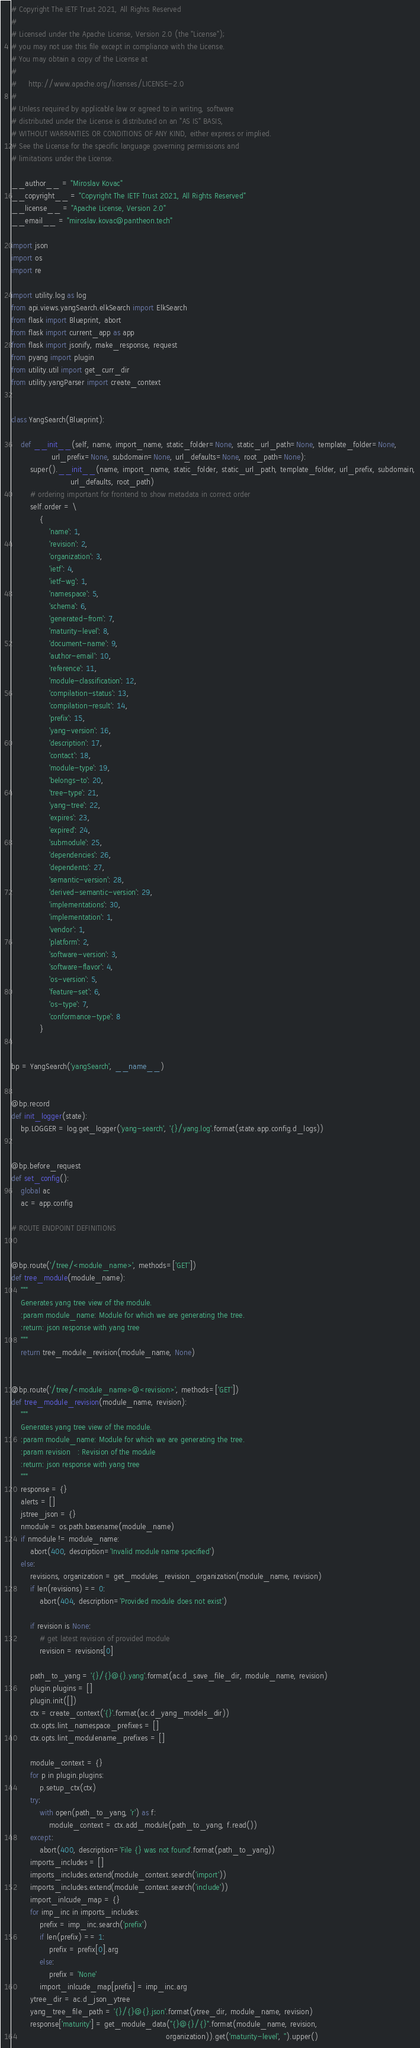<code> <loc_0><loc_0><loc_500><loc_500><_Python_># Copyright The IETF Trust 2021, All Rights Reserved
#
# Licensed under the Apache License, Version 2.0 (the "License");
# you may not use this file except in compliance with the License.
# You may obtain a copy of the License at
#
#     http://www.apache.org/licenses/LICENSE-2.0
#
# Unless required by applicable law or agreed to in writing, software
# distributed under the License is distributed on an "AS IS" BASIS,
# WITHOUT WARRANTIES OR CONDITIONS OF ANY KIND, either express or implied.
# See the License for the specific language governing permissions and
# limitations under the License.

__author__ = "Miroslav Kovac"
__copyright__ = "Copyright The IETF Trust 2021, All Rights Reserved"
__license__ = "Apache License, Version 2.0"
__email__ = "miroslav.kovac@pantheon.tech"

import json
import os
import re

import utility.log as log
from api.views.yangSearch.elkSearch import ElkSearch
from flask import Blueprint, abort
from flask import current_app as app
from flask import jsonify, make_response, request
from pyang import plugin
from utility.util import get_curr_dir
from utility.yangParser import create_context


class YangSearch(Blueprint):

    def __init__(self, name, import_name, static_folder=None, static_url_path=None, template_folder=None,
                 url_prefix=None, subdomain=None, url_defaults=None, root_path=None):
        super().__init__(name, import_name, static_folder, static_url_path, template_folder, url_prefix, subdomain,
                         url_defaults, root_path)
        # ordering important for frontend to show metadata in correct order
        self.order = \
            {
                'name': 1,
                'revision': 2,
                'organization': 3,
                'ietf': 4,
                'ietf-wg': 1,
                'namespace': 5,
                'schema': 6,
                'generated-from': 7,
                'maturity-level': 8,
                'document-name': 9,
                'author-email': 10,
                'reference': 11,
                'module-classification': 12,
                'compilation-status': 13,
                'compilation-result': 14,
                'prefix': 15,
                'yang-version': 16,
                'description': 17,
                'contact': 18,
                'module-type': 19,
                'belongs-to': 20,
                'tree-type': 21,
                'yang-tree': 22,
                'expires': 23,
                'expired': 24,
                'submodule': 25,
                'dependencies': 26,
                'dependents': 27,
                'semantic-version': 28,
                'derived-semantic-version': 29,
                'implementations': 30,
                'implementation': 1,
                'vendor': 1,
                'platform': 2,
                'software-version': 3,
                'software-flavor': 4,
                'os-version': 5,
                'feature-set': 6,
                'os-type': 7,
                'conformance-type': 8
            }


bp = YangSearch('yangSearch', __name__)


@bp.record
def init_logger(state):
    bp.LOGGER = log.get_logger('yang-search', '{}/yang.log'.format(state.app.config.d_logs))


@bp.before_request
def set_config():
    global ac
    ac = app.config

# ROUTE ENDPOINT DEFINITIONS


@bp.route('/tree/<module_name>', methods=['GET'])
def tree_module(module_name):
    """
    Generates yang tree view of the module.
    :param module_name: Module for which we are generating the tree.
    :return: json response with yang tree
    """
    return tree_module_revision(module_name, None)


@bp.route('/tree/<module_name>@<revision>', methods=['GET'])
def tree_module_revision(module_name, revision):
    """
    Generates yang tree view of the module.
    :param module_name: Module for which we are generating the tree.
    :param revision   : Revision of the module
    :return: json response with yang tree
    """
    response = {}
    alerts = []
    jstree_json = {}
    nmodule = os.path.basename(module_name)
    if nmodule != module_name:
        abort(400, description='Invalid module name specified')
    else:
        revisions, organization = get_modules_revision_organization(module_name, revision)
        if len(revisions) == 0:
            abort(404, description='Provided module does not exist')

        if revision is None:
            # get latest revision of provided module
            revision = revisions[0]

        path_to_yang = '{}/{}@{}.yang'.format(ac.d_save_file_dir, module_name, revision)
        plugin.plugins = []
        plugin.init([])
        ctx = create_context('{}'.format(ac.d_yang_models_dir))
        ctx.opts.lint_namespace_prefixes = []
        ctx.opts.lint_modulename_prefixes = []

        module_context = {}
        for p in plugin.plugins:
            p.setup_ctx(ctx)
        try:
            with open(path_to_yang, 'r') as f:
                module_context = ctx.add_module(path_to_yang, f.read())
        except:
            abort(400, description='File {} was not found'.format(path_to_yang))
        imports_includes = []
        imports_includes.extend(module_context.search('import'))
        imports_includes.extend(module_context.search('include'))
        import_inlcude_map = {}
        for imp_inc in imports_includes:
            prefix = imp_inc.search('prefix')
            if len(prefix) == 1:
                prefix = prefix[0].arg
            else:
                prefix = 'None'
            import_inlcude_map[prefix] = imp_inc.arg
        ytree_dir = ac.d_json_ytree
        yang_tree_file_path = '{}/{}@{}.json'.format(ytree_dir, module_name, revision)
        response['maturity'] = get_module_data("{}@{}/{}".format(module_name, revision,
                                                                 organization)).get('maturity-level', '').upper()</code> 